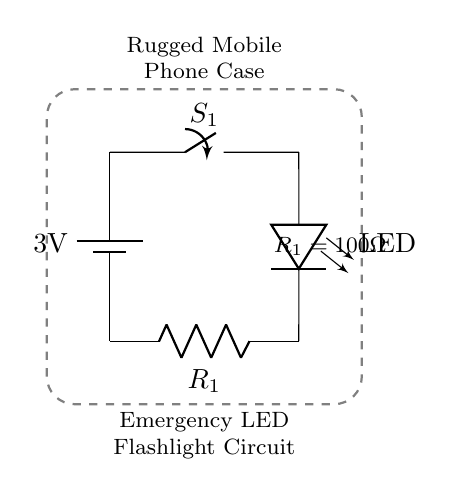What is the voltage supplied by the battery? The circuit diagram labels the battery with a voltage of 3V, which indicates the potential difference it provides.
Answer: 3V What component acts as a switch in this circuit? The circuit shows a symbol labeled S_1, which represents the switch. Thus, S_1 is the component that can interrupt the circuit.
Answer: S_1 What is the purpose of the resistor in this circuit? The resistor, labeled R_1, is used to limit the current flowing through the LED, preventing damage due to excess current.
Answer: Limit current How many components are there in this circuit? Counting the symbols, there are four distinct components: a battery, a switch, an LED, and a resistor.
Answer: Four What is the resistance value of R_1? The circuit diagram specifies that R_1 has a value of 100 ohms, which provides the necessary resistance for current regulation.
Answer: 100 ohms What happens when the switch is closed? Closing the switch completes the circuit, allowing current to flow from the battery through the LED and resistor, lighting up the LED for emergency use.
Answer: LED lights up What type of device is this circuit intended for? The circuit is integrated into a rugged mobile phone case, indicating that it is designed for an emergency flashlight feature in a mobile device.
Answer: Mobile phone case 